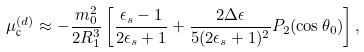<formula> <loc_0><loc_0><loc_500><loc_500>\mu _ { \text {c} } ^ { ( d ) } \approx - \frac { m _ { 0 } ^ { 2 } } { 2 R _ { 1 } ^ { 3 } } \left [ \frac { \epsilon _ { s } - 1 } { 2 \epsilon _ { s } + 1 } + \frac { 2 \Delta \epsilon } { 5 ( 2 \epsilon _ { s } + 1 ) ^ { 2 } } P _ { 2 } ( \cos \theta _ { 0 } ) \right ] ,</formula> 